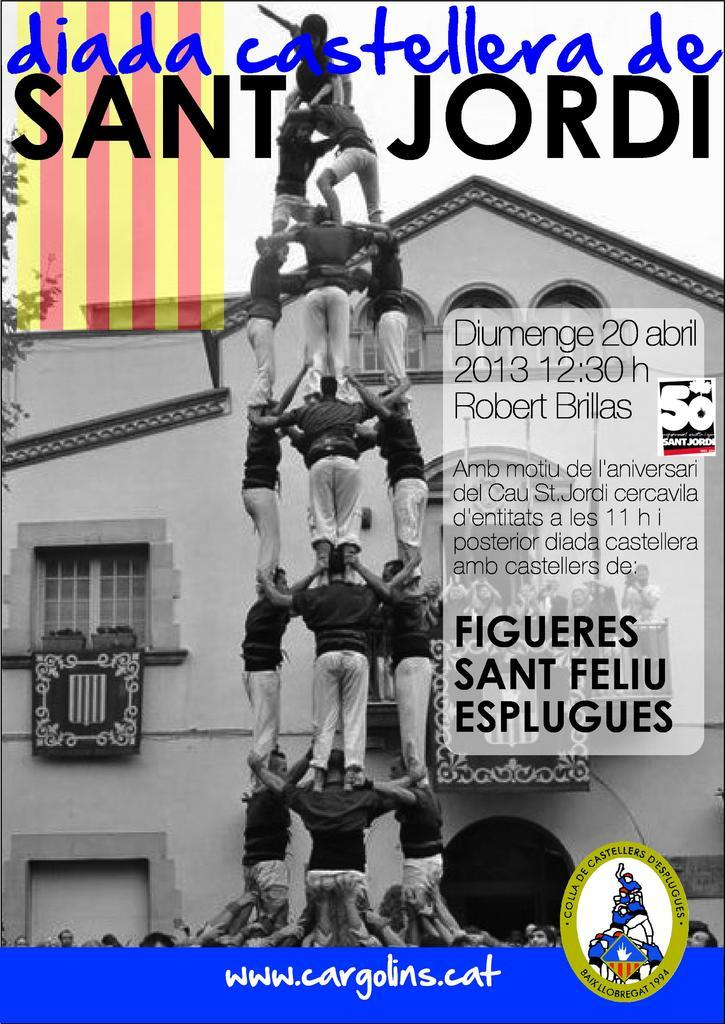What type of image is shown in the picture? The image is of a poster. What activity are the people in the poster engaged in? People are preparing to climb a tower in the poster. How are the people climbing the tower? The people are climbing one above the other. What can be seen in the background of the poster? There is a building visible in the background of the poster. Where is the text located on the poster? The text is on the top of the poster. What type of calculator is being used by the beginner climber in the image? There is no calculator present in the image, and the people in the poster are not described as beginners. 